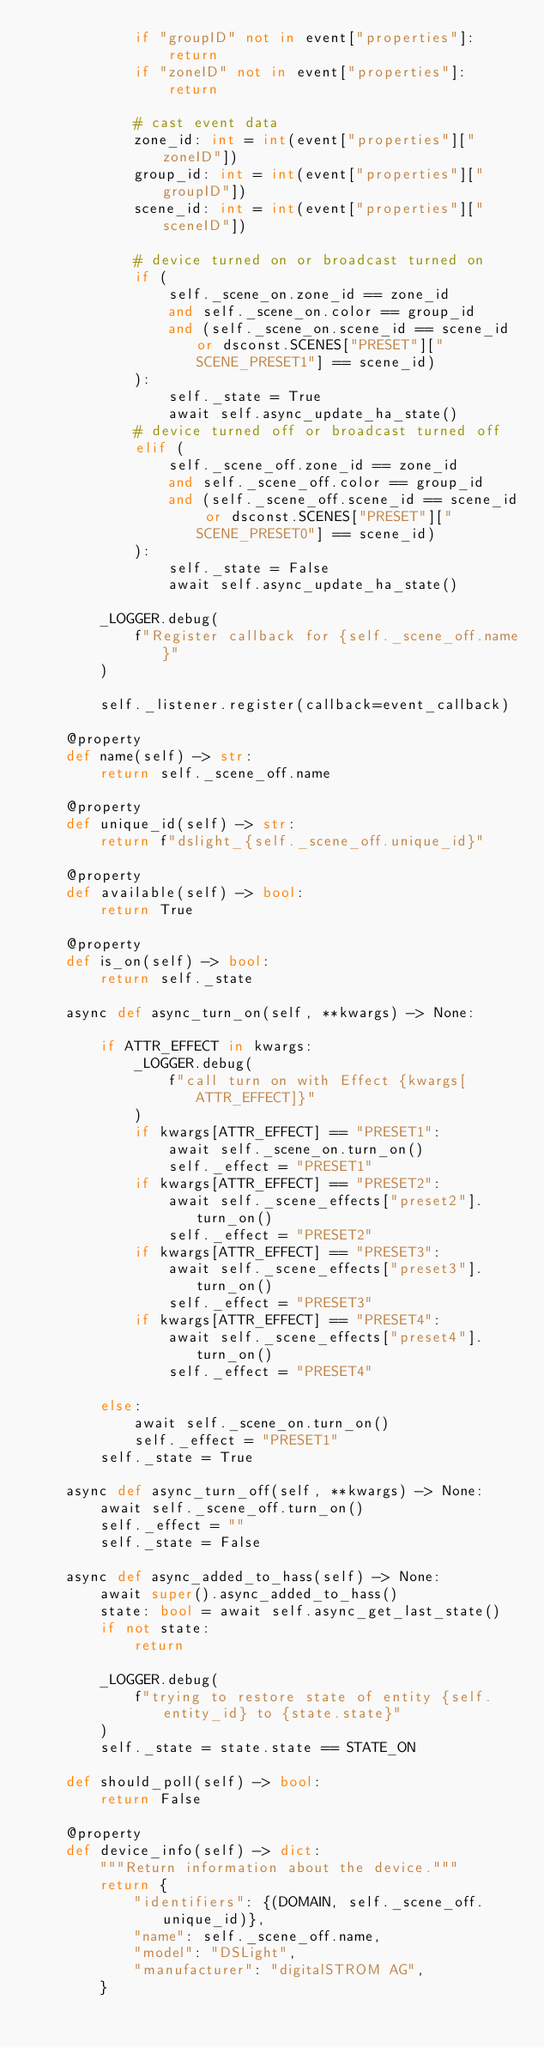<code> <loc_0><loc_0><loc_500><loc_500><_Python_>            if "groupID" not in event["properties"]:
                return
            if "zoneID" not in event["properties"]:
                return

            # cast event data
            zone_id: int = int(event["properties"]["zoneID"])
            group_id: int = int(event["properties"]["groupID"])
            scene_id: int = int(event["properties"]["sceneID"])

            # device turned on or broadcast turned on
            if (
                self._scene_on.zone_id == zone_id
                and self._scene_on.color == group_id
                and (self._scene_on.scene_id == scene_id or dsconst.SCENES["PRESET"]["SCENE_PRESET1"] == scene_id)
            ):
                self._state = True
                await self.async_update_ha_state()
            # device turned off or broadcast turned off
            elif (
                self._scene_off.zone_id == zone_id
                and self._scene_off.color == group_id
                and (self._scene_off.scene_id == scene_id or dsconst.SCENES["PRESET"]["SCENE_PRESET0"] == scene_id)
            ):
                self._state = False
                await self.async_update_ha_state()

        _LOGGER.debug(
            f"Register callback for {self._scene_off.name}"
        )

        self._listener.register(callback=event_callback)

    @property
    def name(self) -> str:
        return self._scene_off.name

    @property
    def unique_id(self) -> str:
        return f"dslight_{self._scene_off.unique_id}"

    @property
    def available(self) -> bool:
        return True

    @property
    def is_on(self) -> bool:
        return self._state

    async def async_turn_on(self, **kwargs) -> None:

        if ATTR_EFFECT in kwargs:
            _LOGGER.debug(
                f"call turn on with Effect {kwargs[ATTR_EFFECT]}"
            )
            if kwargs[ATTR_EFFECT] == "PRESET1":
                await self._scene_on.turn_on()
                self._effect = "PRESET1"
            if kwargs[ATTR_EFFECT] == "PRESET2":
                await self._scene_effects["preset2"].turn_on()
                self._effect = "PRESET2"
            if kwargs[ATTR_EFFECT] == "PRESET3":
                await self._scene_effects["preset3"].turn_on()
                self._effect = "PRESET3"
            if kwargs[ATTR_EFFECT] == "PRESET4":
                await self._scene_effects["preset4"].turn_on()
                self._effect = "PRESET4"
                
        else:
            await self._scene_on.turn_on()
            self._effect = "PRESET1"
        self._state = True

    async def async_turn_off(self, **kwargs) -> None:
        await self._scene_off.turn_on()
        self._effect = ""
        self._state = False

    async def async_added_to_hass(self) -> None:
        await super().async_added_to_hass()
        state: bool = await self.async_get_last_state()
        if not state:
            return

        _LOGGER.debug(
            f"trying to restore state of entity {self.entity_id} to {state.state}"
        )
        self._state = state.state == STATE_ON

    def should_poll(self) -> bool:
        return False

    @property
    def device_info(self) -> dict:
        """Return information about the device."""
        return {
            "identifiers": {(DOMAIN, self._scene_off.unique_id)},
            "name": self._scene_off.name,
            "model": "DSLight",
            "manufacturer": "digitalSTROM AG",
        }
</code> 